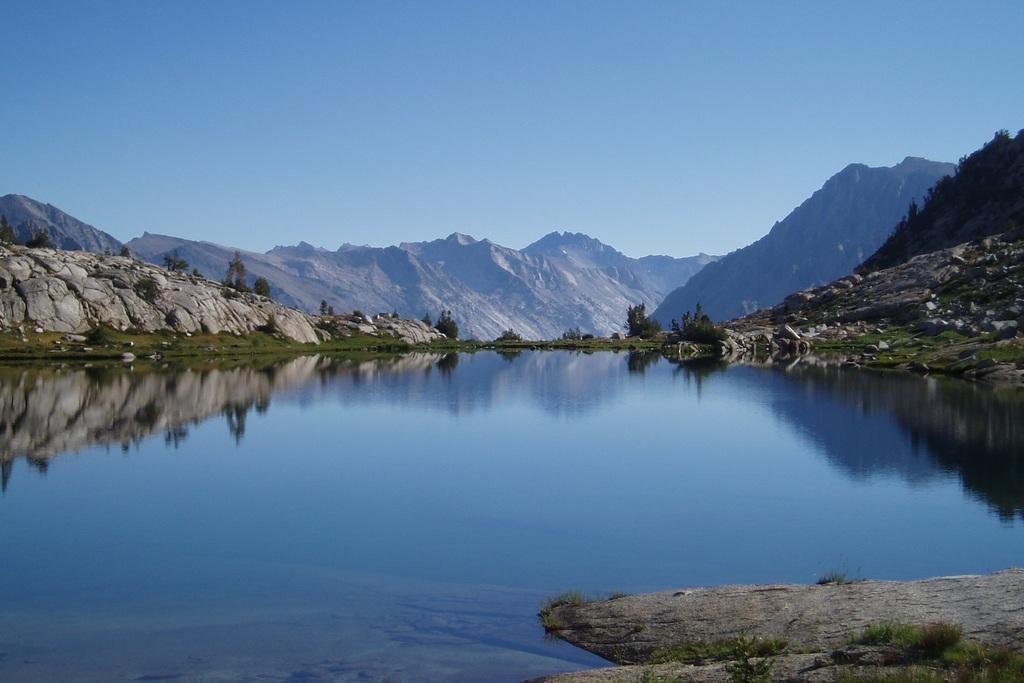Could you give a brief overview of what you see in this image? In this image we can see the mountains. Image also consists of trees. At the top there is sky and at the bottom there is water. 